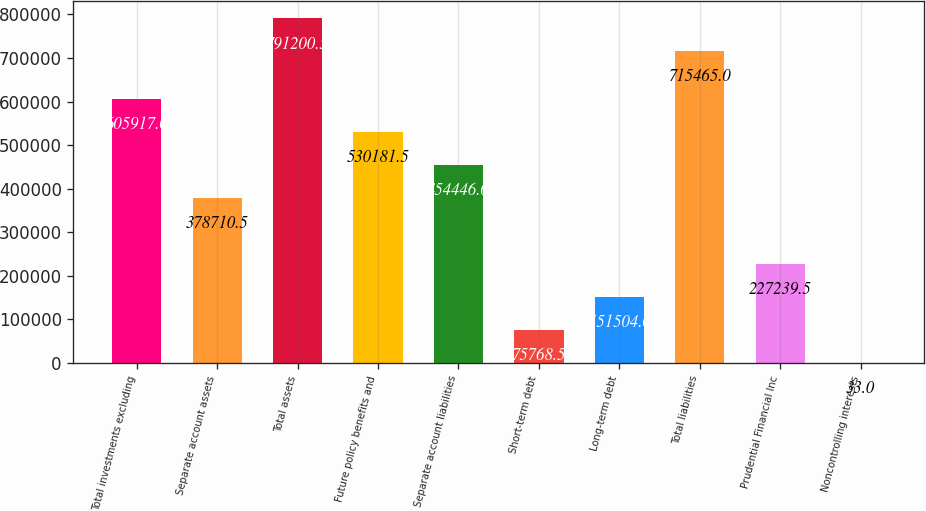Convert chart to OTSL. <chart><loc_0><loc_0><loc_500><loc_500><bar_chart><fcel>Total investments excluding<fcel>Separate account assets<fcel>Total assets<fcel>Future policy benefits and<fcel>Separate account liabilities<fcel>Short-term debt<fcel>Long-term debt<fcel>Total liabilities<fcel>Prudential Financial Inc<fcel>Noncontrolling interests<nl><fcel>605917<fcel>378710<fcel>791200<fcel>530182<fcel>454446<fcel>75768.5<fcel>151504<fcel>715465<fcel>227240<fcel>33<nl></chart> 